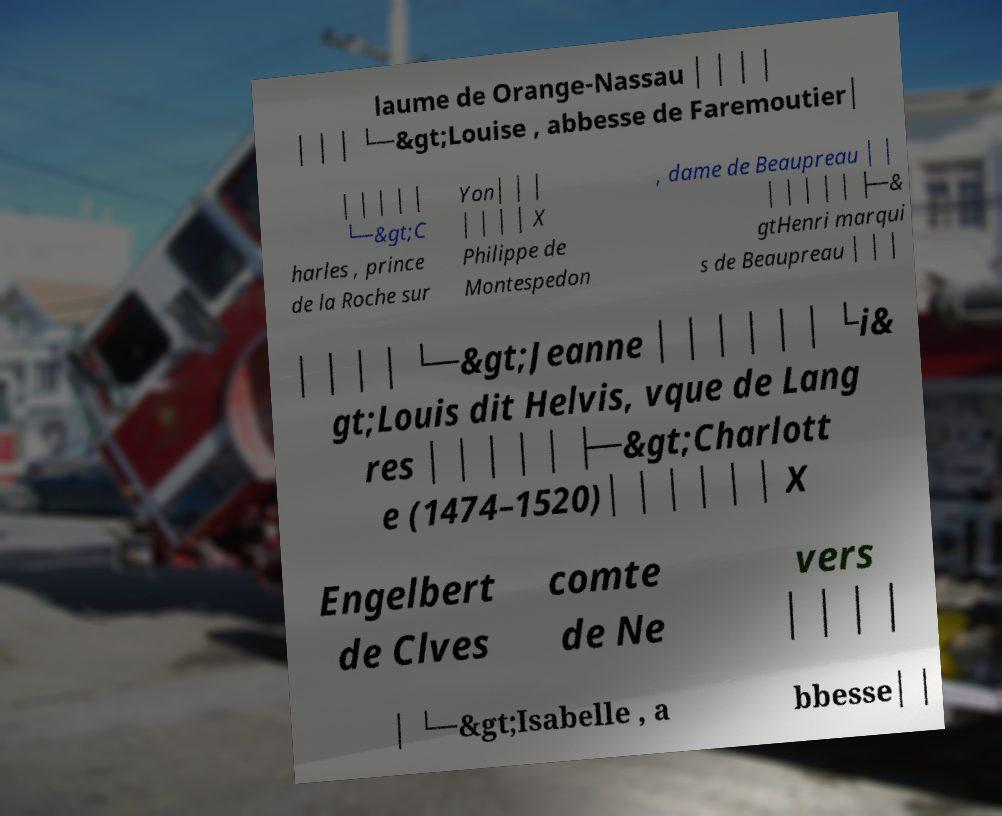Can you accurately transcribe the text from the provided image for me? laume de Orange-Nassau │ │ │ │ │ │ │ └─&gt;Louise , abbesse de Faremoutier│ │ │ │ │ │ └─&gt;C harles , prince de la Roche sur Yon│ │ │ │ │ │ │ X Philippe de Montespedon , dame de Beaupreau │ │ │ │ │ │ │ ├─& gtHenri marqui s de Beaupreau │ │ │ │ │ │ │ └─&gt;Jeanne │ │ │ │ │ │ └i& gt;Louis dit Helvis, vque de Lang res │ │ │ │ │ ├─&gt;Charlott e (1474–1520)│ │ │ │ │ │ X Engelbert de Clves comte de Ne vers │ │ │ │ │ └─&gt;Isabelle , a bbesse│ │ 